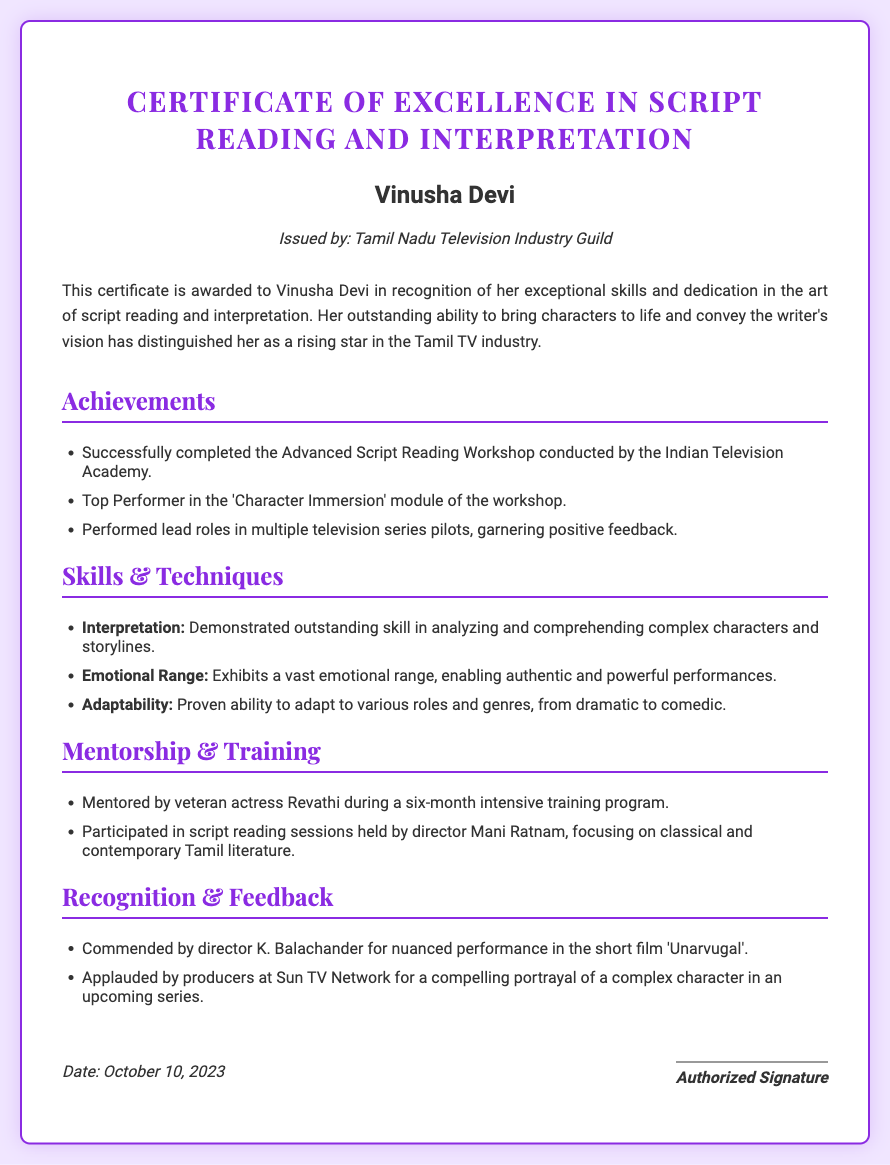What is the title of the certificate? The title of the certificate is explicitly mentioned at the top of the document, which is a formal acknowledgment of achievement in a specific field.
Answer: Certificate of Excellence in Script Reading and Interpretation Who is the recipient of the certificate? The recipient's name is stated clearly in the document, signifying who has been awarded the certificate.
Answer: Vinusha Devi Which organization issued the certificate? The document mentions the organization responsible for issuing the certificate, indicating credibility and authority.
Answer: Tamil Nadu Television Industry Guild What is the date of issuance of the certificate? The date appears in the document, marking when the certificate was officially granted.
Answer: October 10, 2023 What notable workshop did Vinusha Devi complete? The document lists a significant training event that contributes to the recipient's skills in the industry, highlighting her commitment to professional development.
Answer: Advanced Script Reading Workshop Which actress mentored Vinusha Devi during her training? The document specifies a well-known figure who provided mentorship, illustrating the caliber of guidance the recipient received.
Answer: Revathi What was Vinusha Devi’s performance recognized by director K. Balachander? The document includes feedback from a respected director, indicating the impact of her performance in a specific project.
Answer: nuanced performance in the short film 'Unarvugal' Name one skill that Vinusha Devi demonstrated in her training. The document highlights specific skills related to her craft, showcasing her strengths as an actress.
Answer: Interpretation Which production company commended Vinusha Devi’s portrayal of a character? Feedback from industry professionals is mentioned, which is important for validating her skills and future opportunities.
Answer: Sun TV Network 